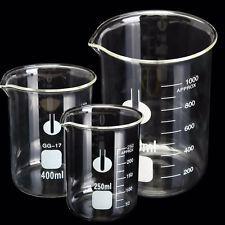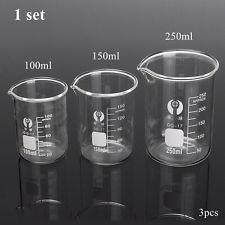The first image is the image on the left, the second image is the image on the right. Analyze the images presented: Is the assertion "There are exactly three flasks in the image on the left." valid? Answer yes or no. Yes. 